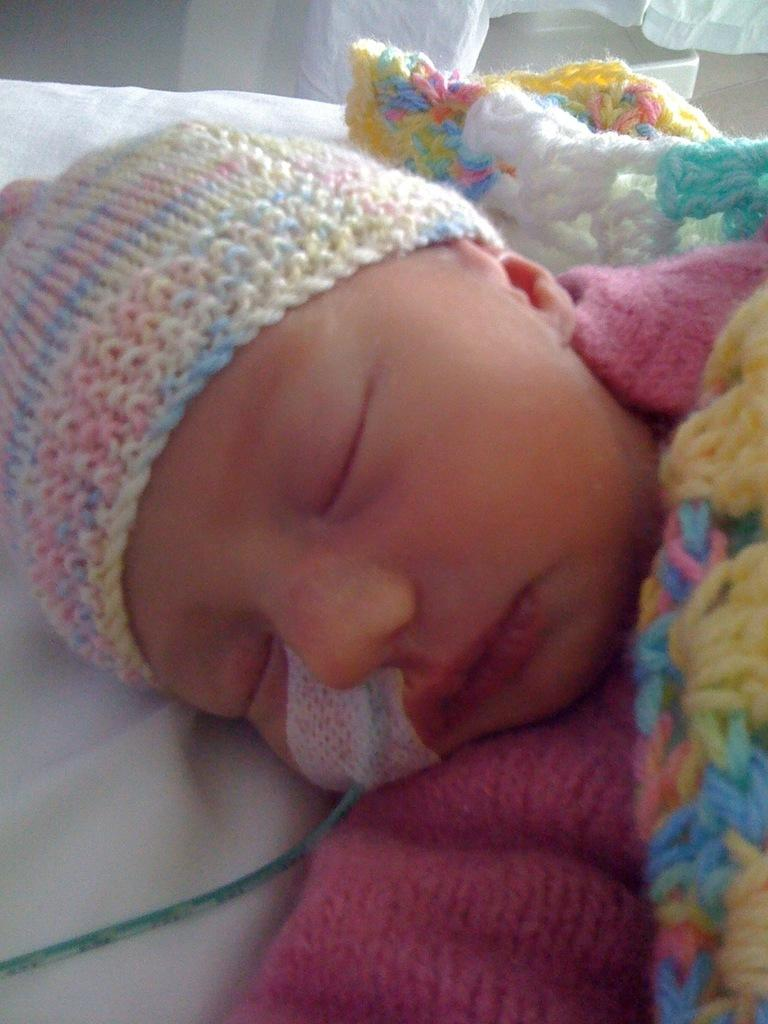What is the main subject of the image? The main subject of the image is a kid. What is the kid wearing on their head? The kid is wearing a woolen cap. What type of discovery was made by the kid in the image? There is no indication in the image that the kid made any discovery. 